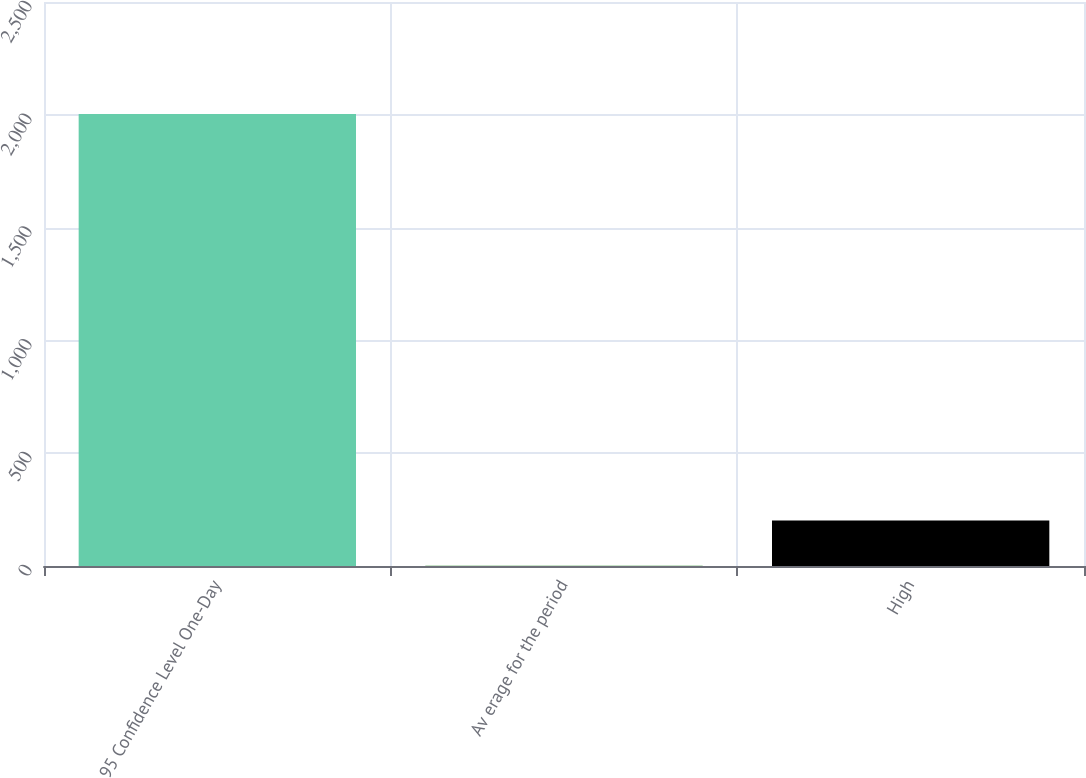Convert chart to OTSL. <chart><loc_0><loc_0><loc_500><loc_500><bar_chart><fcel>95 Confidence Level One-Day<fcel>Av erage for the period<fcel>High<nl><fcel>2003<fcel>1<fcel>201.2<nl></chart> 